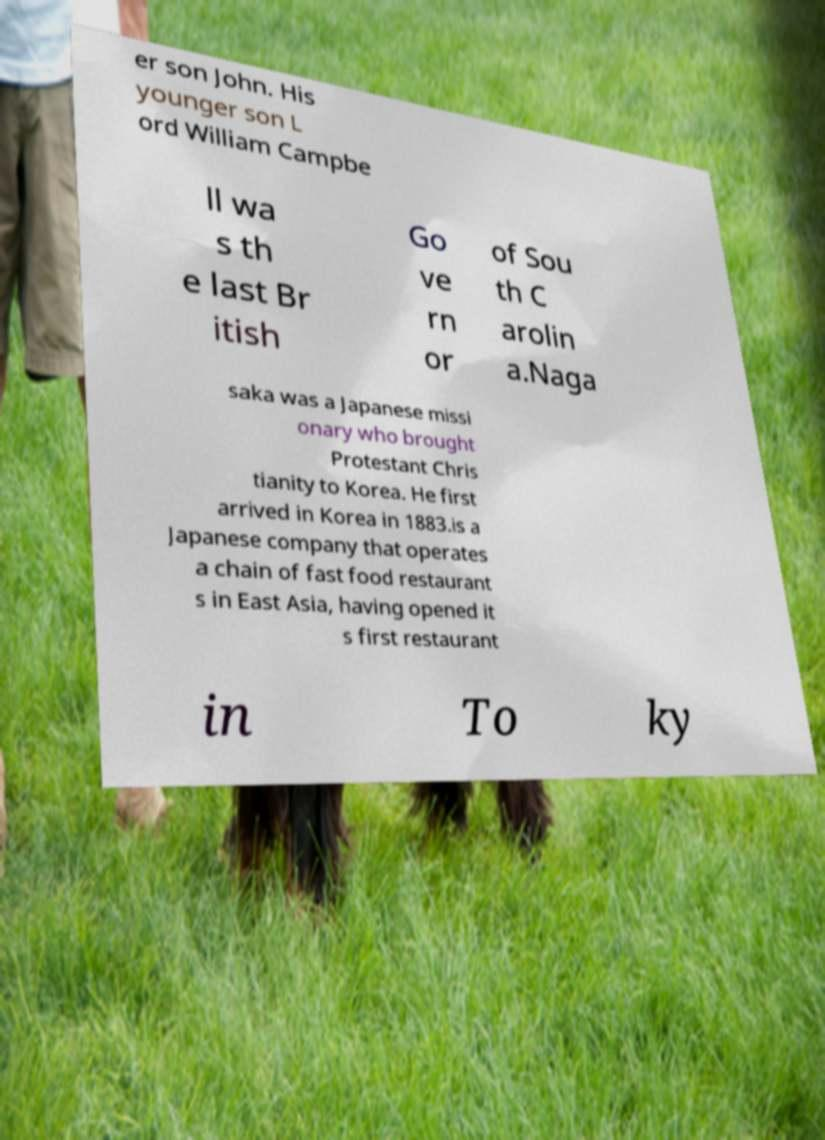Can you read and provide the text displayed in the image?This photo seems to have some interesting text. Can you extract and type it out for me? er son John. His younger son L ord William Campbe ll wa s th e last Br itish Go ve rn or of Sou th C arolin a.Naga saka was a Japanese missi onary who brought Protestant Chris tianity to Korea. He first arrived in Korea in 1883.is a Japanese company that operates a chain of fast food restaurant s in East Asia, having opened it s first restaurant in To ky 